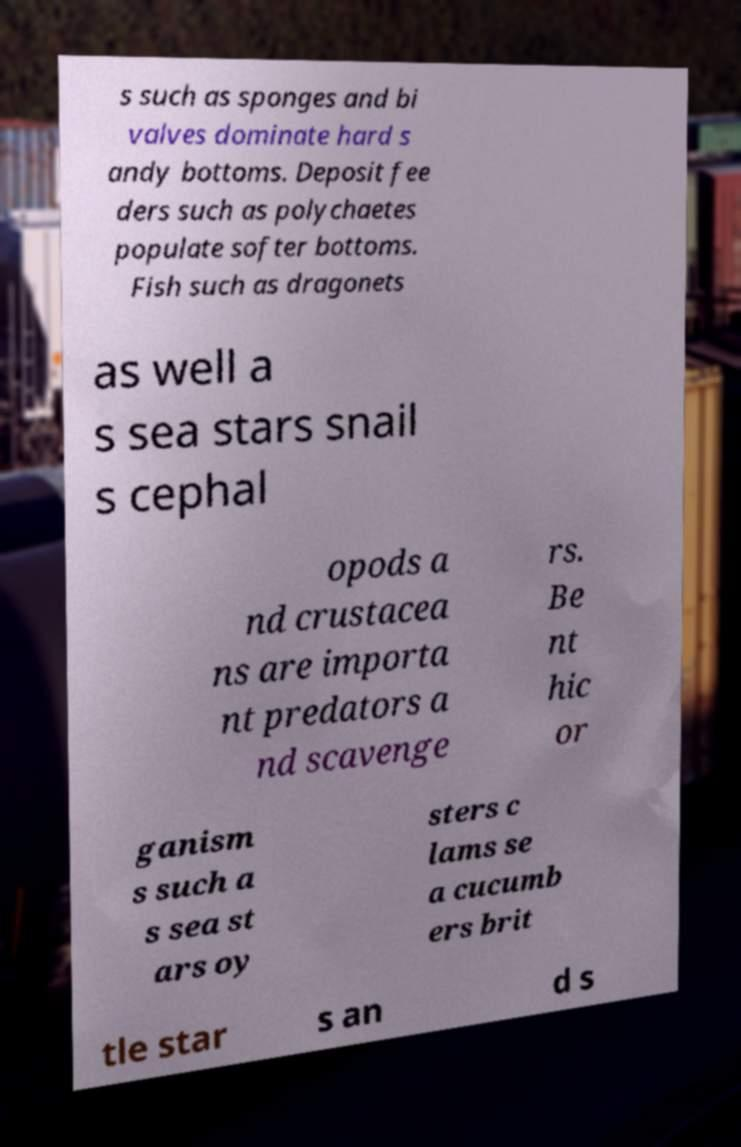Could you assist in decoding the text presented in this image and type it out clearly? s such as sponges and bi valves dominate hard s andy bottoms. Deposit fee ders such as polychaetes populate softer bottoms. Fish such as dragonets as well a s sea stars snail s cephal opods a nd crustacea ns are importa nt predators a nd scavenge rs. Be nt hic or ganism s such a s sea st ars oy sters c lams se a cucumb ers brit tle star s an d s 